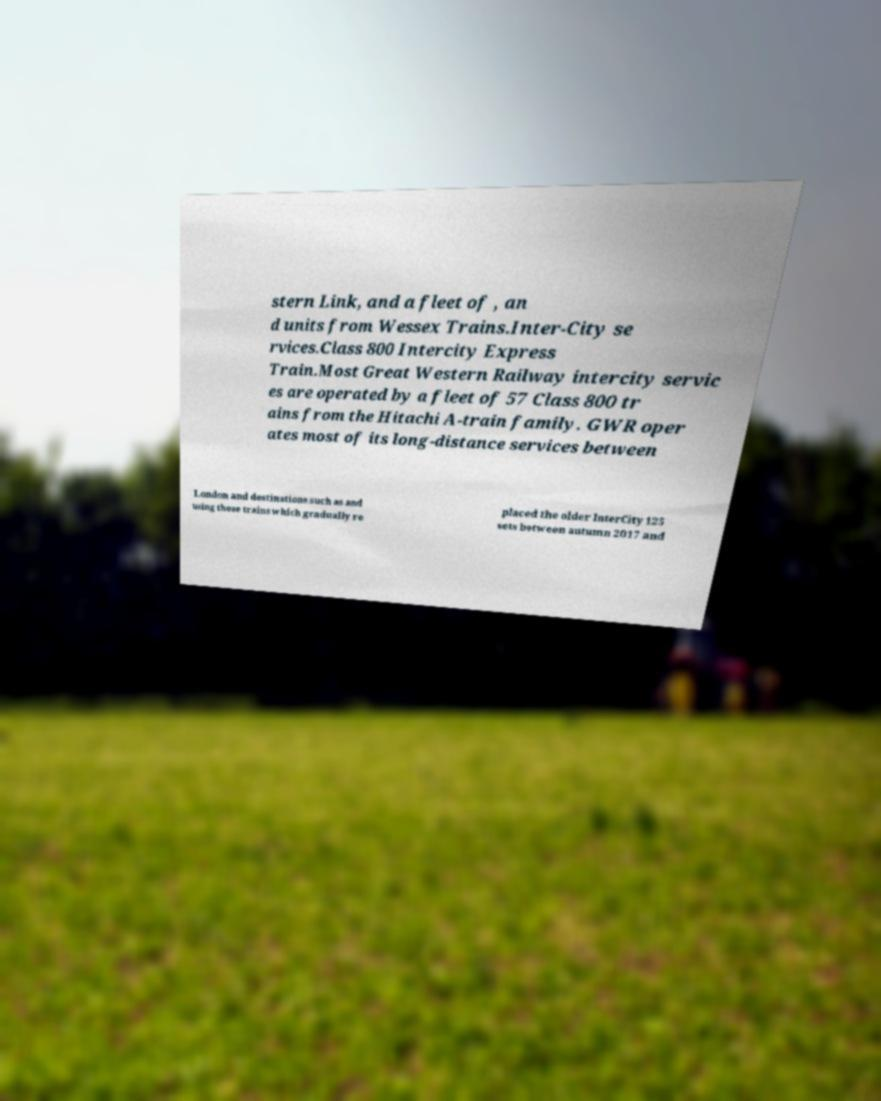Could you extract and type out the text from this image? stern Link, and a fleet of , an d units from Wessex Trains.Inter-City se rvices.Class 800 Intercity Express Train.Most Great Western Railway intercity servic es are operated by a fleet of 57 Class 800 tr ains from the Hitachi A-train family. GWR oper ates most of its long-distance services between London and destinations such as and using these trains which gradually re placed the older InterCity 125 sets between autumn 2017 and 